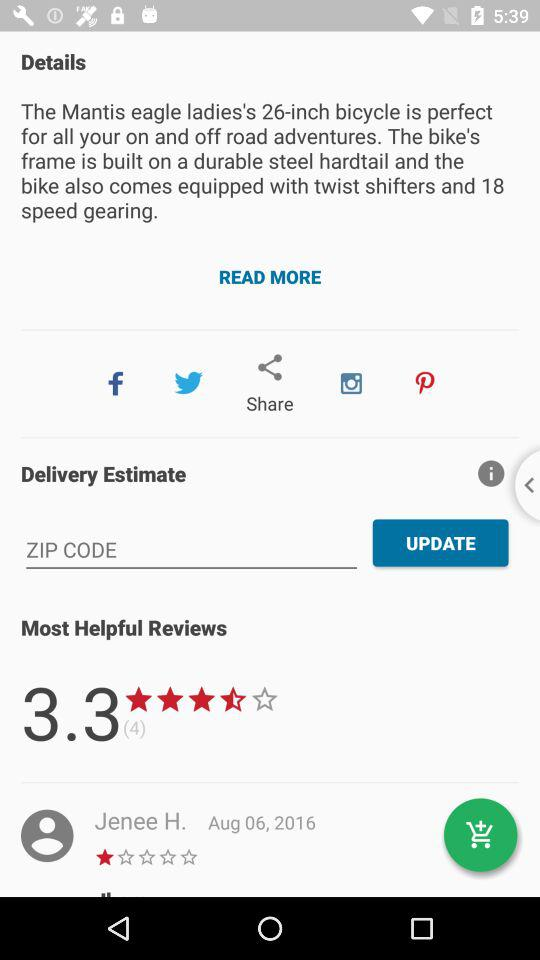How many stars did Jenee H. rate? Jeene H. gave it 1 star. 